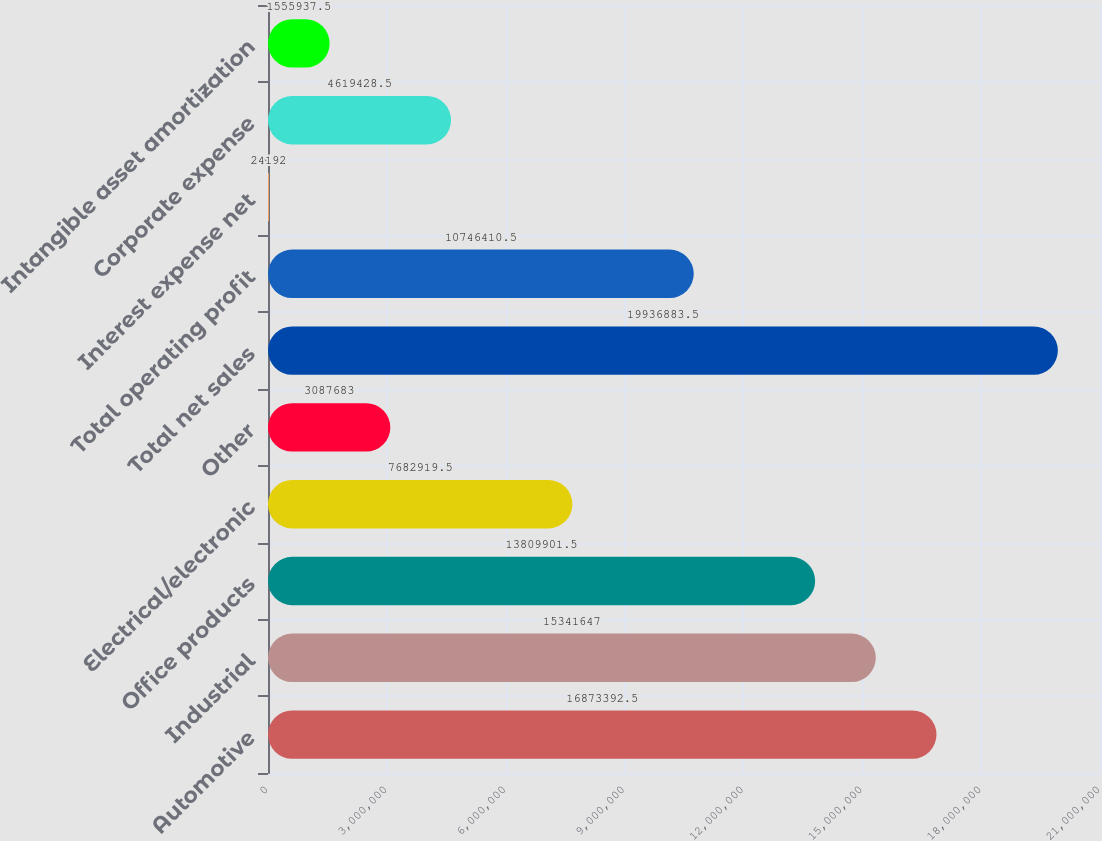Convert chart. <chart><loc_0><loc_0><loc_500><loc_500><bar_chart><fcel>Automotive<fcel>Industrial<fcel>Office products<fcel>Electrical/electronic<fcel>Other<fcel>Total net sales<fcel>Total operating profit<fcel>Interest expense net<fcel>Corporate expense<fcel>Intangible asset amortization<nl><fcel>1.68734e+07<fcel>1.53416e+07<fcel>1.38099e+07<fcel>7.68292e+06<fcel>3.08768e+06<fcel>1.99369e+07<fcel>1.07464e+07<fcel>24192<fcel>4.61943e+06<fcel>1.55594e+06<nl></chart> 